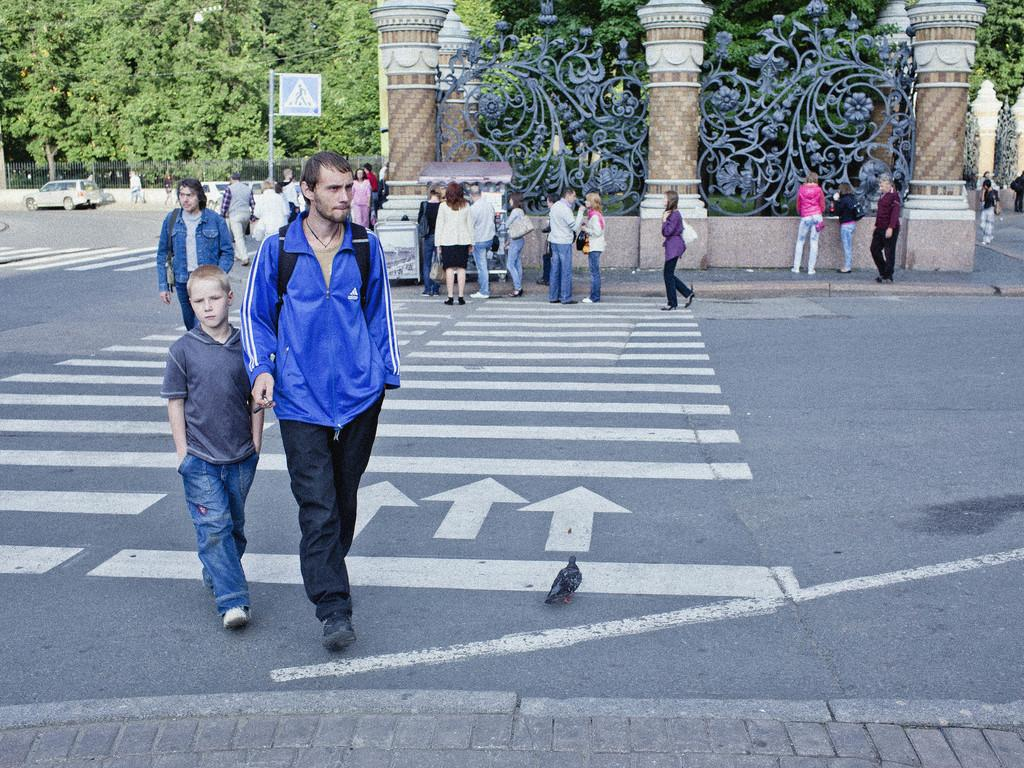What are the people in the image doing? The people in the image are walking on the road. What can be seen in the background of the image? Trees are visible in the image. What type of transportation is present on the road? A motor vehicle is present on the road. What structures can be seen in the image? Fences are visible in the image. What else is present in the image besides the people, trees, motor vehicle, and fences? Cables are visible in the image. Where are the dolls located in the image? There are no dolls present in the image. What type of plants can be seen growing on the side of the road in the image? There is no mention of plants in the image; only trees are mentioned. 